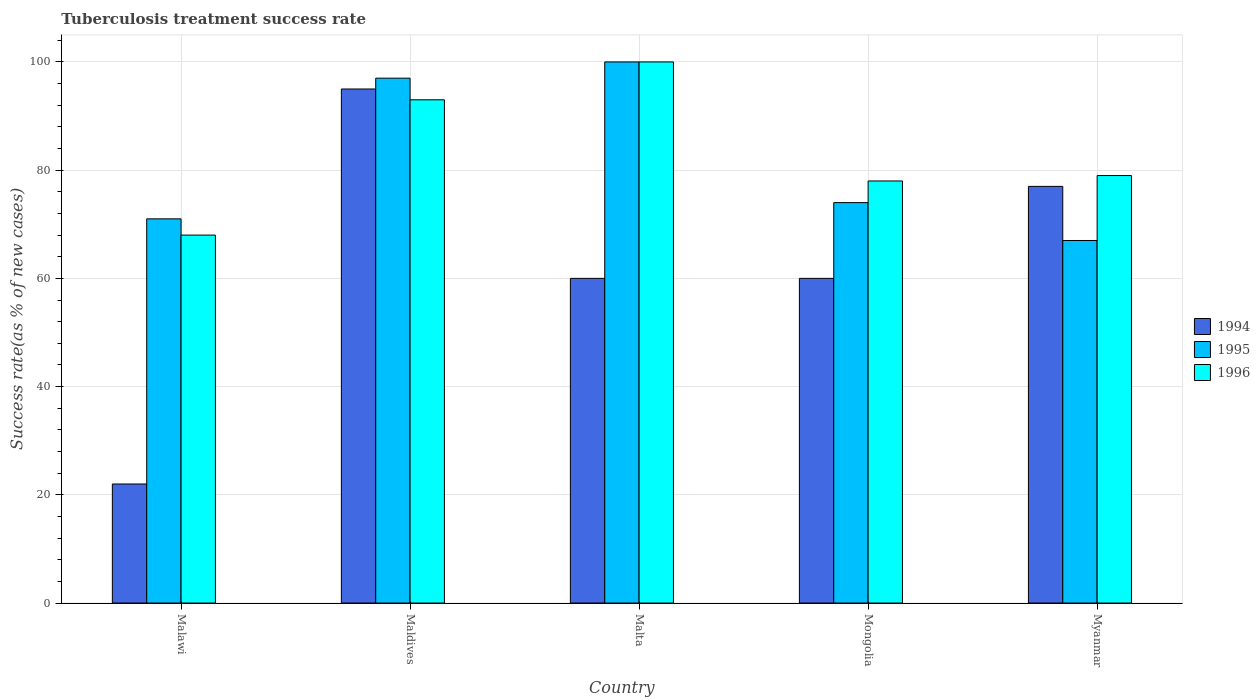How many groups of bars are there?
Give a very brief answer. 5. Are the number of bars on each tick of the X-axis equal?
Your answer should be compact. Yes. What is the label of the 3rd group of bars from the left?
Offer a very short reply. Malta. In how many cases, is the number of bars for a given country not equal to the number of legend labels?
Offer a very short reply. 0. What is the tuberculosis treatment success rate in 1996 in Mongolia?
Offer a terse response. 78. Across all countries, what is the minimum tuberculosis treatment success rate in 1994?
Provide a short and direct response. 22. In which country was the tuberculosis treatment success rate in 1995 maximum?
Provide a succinct answer. Malta. In which country was the tuberculosis treatment success rate in 1994 minimum?
Ensure brevity in your answer.  Malawi. What is the total tuberculosis treatment success rate in 1995 in the graph?
Provide a short and direct response. 409. What is the difference between the tuberculosis treatment success rate in 1994 in Mongolia and the tuberculosis treatment success rate in 1996 in Malawi?
Keep it short and to the point. -8. What is the average tuberculosis treatment success rate in 1995 per country?
Offer a terse response. 81.8. What is the difference between the tuberculosis treatment success rate of/in 1995 and tuberculosis treatment success rate of/in 1994 in Maldives?
Offer a very short reply. 2. What is the ratio of the tuberculosis treatment success rate in 1996 in Malawi to that in Maldives?
Offer a terse response. 0.73. What is the difference between the highest and the second highest tuberculosis treatment success rate in 1996?
Offer a terse response. 7. What is the difference between the highest and the lowest tuberculosis treatment success rate in 1994?
Keep it short and to the point. 73. In how many countries, is the tuberculosis treatment success rate in 1994 greater than the average tuberculosis treatment success rate in 1994 taken over all countries?
Your response must be concise. 2. Is the sum of the tuberculosis treatment success rate in 1994 in Malawi and Myanmar greater than the maximum tuberculosis treatment success rate in 1995 across all countries?
Ensure brevity in your answer.  No. What does the 1st bar from the right in Mongolia represents?
Give a very brief answer. 1996. How many bars are there?
Provide a succinct answer. 15. Are all the bars in the graph horizontal?
Keep it short and to the point. No. What is the title of the graph?
Your response must be concise. Tuberculosis treatment success rate. Does "1964" appear as one of the legend labels in the graph?
Provide a short and direct response. No. What is the label or title of the X-axis?
Keep it short and to the point. Country. What is the label or title of the Y-axis?
Offer a very short reply. Success rate(as % of new cases). What is the Success rate(as % of new cases) of 1994 in Malawi?
Make the answer very short. 22. What is the Success rate(as % of new cases) of 1995 in Malawi?
Give a very brief answer. 71. What is the Success rate(as % of new cases) in 1995 in Maldives?
Provide a short and direct response. 97. What is the Success rate(as % of new cases) of 1996 in Maldives?
Offer a terse response. 93. What is the Success rate(as % of new cases) in 1994 in Malta?
Keep it short and to the point. 60. What is the Success rate(as % of new cases) in 1996 in Malta?
Offer a terse response. 100. What is the Success rate(as % of new cases) of 1994 in Mongolia?
Offer a very short reply. 60. What is the Success rate(as % of new cases) in 1996 in Mongolia?
Provide a short and direct response. 78. What is the Success rate(as % of new cases) of 1996 in Myanmar?
Make the answer very short. 79. Across all countries, what is the maximum Success rate(as % of new cases) in 1996?
Make the answer very short. 100. Across all countries, what is the minimum Success rate(as % of new cases) of 1994?
Keep it short and to the point. 22. What is the total Success rate(as % of new cases) in 1994 in the graph?
Give a very brief answer. 314. What is the total Success rate(as % of new cases) of 1995 in the graph?
Offer a terse response. 409. What is the total Success rate(as % of new cases) of 1996 in the graph?
Make the answer very short. 418. What is the difference between the Success rate(as % of new cases) in 1994 in Malawi and that in Maldives?
Offer a terse response. -73. What is the difference between the Success rate(as % of new cases) in 1996 in Malawi and that in Maldives?
Ensure brevity in your answer.  -25. What is the difference between the Success rate(as % of new cases) in 1994 in Malawi and that in Malta?
Offer a very short reply. -38. What is the difference between the Success rate(as % of new cases) of 1996 in Malawi and that in Malta?
Make the answer very short. -32. What is the difference between the Success rate(as % of new cases) of 1994 in Malawi and that in Mongolia?
Provide a short and direct response. -38. What is the difference between the Success rate(as % of new cases) in 1995 in Malawi and that in Mongolia?
Make the answer very short. -3. What is the difference between the Success rate(as % of new cases) in 1996 in Malawi and that in Mongolia?
Provide a succinct answer. -10. What is the difference between the Success rate(as % of new cases) in 1994 in Malawi and that in Myanmar?
Your response must be concise. -55. What is the difference between the Success rate(as % of new cases) of 1995 in Malawi and that in Myanmar?
Your answer should be very brief. 4. What is the difference between the Success rate(as % of new cases) of 1994 in Maldives and that in Mongolia?
Keep it short and to the point. 35. What is the difference between the Success rate(as % of new cases) in 1995 in Maldives and that in Mongolia?
Ensure brevity in your answer.  23. What is the difference between the Success rate(as % of new cases) of 1996 in Maldives and that in Myanmar?
Keep it short and to the point. 14. What is the difference between the Success rate(as % of new cases) in 1996 in Malta and that in Mongolia?
Make the answer very short. 22. What is the difference between the Success rate(as % of new cases) of 1994 in Malta and that in Myanmar?
Offer a terse response. -17. What is the difference between the Success rate(as % of new cases) of 1995 in Malta and that in Myanmar?
Offer a terse response. 33. What is the difference between the Success rate(as % of new cases) in 1996 in Mongolia and that in Myanmar?
Offer a very short reply. -1. What is the difference between the Success rate(as % of new cases) in 1994 in Malawi and the Success rate(as % of new cases) in 1995 in Maldives?
Offer a terse response. -75. What is the difference between the Success rate(as % of new cases) in 1994 in Malawi and the Success rate(as % of new cases) in 1996 in Maldives?
Keep it short and to the point. -71. What is the difference between the Success rate(as % of new cases) of 1995 in Malawi and the Success rate(as % of new cases) of 1996 in Maldives?
Your response must be concise. -22. What is the difference between the Success rate(as % of new cases) in 1994 in Malawi and the Success rate(as % of new cases) in 1995 in Malta?
Offer a very short reply. -78. What is the difference between the Success rate(as % of new cases) of 1994 in Malawi and the Success rate(as % of new cases) of 1996 in Malta?
Offer a terse response. -78. What is the difference between the Success rate(as % of new cases) of 1994 in Malawi and the Success rate(as % of new cases) of 1995 in Mongolia?
Keep it short and to the point. -52. What is the difference between the Success rate(as % of new cases) in 1994 in Malawi and the Success rate(as % of new cases) in 1996 in Mongolia?
Provide a short and direct response. -56. What is the difference between the Success rate(as % of new cases) of 1994 in Malawi and the Success rate(as % of new cases) of 1995 in Myanmar?
Provide a succinct answer. -45. What is the difference between the Success rate(as % of new cases) of 1994 in Malawi and the Success rate(as % of new cases) of 1996 in Myanmar?
Keep it short and to the point. -57. What is the difference between the Success rate(as % of new cases) of 1995 in Maldives and the Success rate(as % of new cases) of 1996 in Malta?
Give a very brief answer. -3. What is the difference between the Success rate(as % of new cases) in 1994 in Maldives and the Success rate(as % of new cases) in 1996 in Mongolia?
Make the answer very short. 17. What is the difference between the Success rate(as % of new cases) of 1995 in Maldives and the Success rate(as % of new cases) of 1996 in Mongolia?
Offer a terse response. 19. What is the difference between the Success rate(as % of new cases) in 1994 in Maldives and the Success rate(as % of new cases) in 1995 in Myanmar?
Your response must be concise. 28. What is the difference between the Success rate(as % of new cases) of 1994 in Maldives and the Success rate(as % of new cases) of 1996 in Myanmar?
Your answer should be very brief. 16. What is the difference between the Success rate(as % of new cases) in 1994 in Malta and the Success rate(as % of new cases) in 1995 in Mongolia?
Your response must be concise. -14. What is the difference between the Success rate(as % of new cases) of 1994 in Malta and the Success rate(as % of new cases) of 1996 in Mongolia?
Your answer should be very brief. -18. What is the difference between the Success rate(as % of new cases) of 1994 in Malta and the Success rate(as % of new cases) of 1995 in Myanmar?
Offer a very short reply. -7. What is the difference between the Success rate(as % of new cases) of 1994 in Mongolia and the Success rate(as % of new cases) of 1995 in Myanmar?
Offer a very short reply. -7. What is the average Success rate(as % of new cases) of 1994 per country?
Give a very brief answer. 62.8. What is the average Success rate(as % of new cases) of 1995 per country?
Your answer should be compact. 81.8. What is the average Success rate(as % of new cases) in 1996 per country?
Your answer should be compact. 83.6. What is the difference between the Success rate(as % of new cases) of 1994 and Success rate(as % of new cases) of 1995 in Malawi?
Provide a short and direct response. -49. What is the difference between the Success rate(as % of new cases) of 1994 and Success rate(as % of new cases) of 1996 in Malawi?
Ensure brevity in your answer.  -46. What is the difference between the Success rate(as % of new cases) of 1995 and Success rate(as % of new cases) of 1996 in Malawi?
Provide a succinct answer. 3. What is the difference between the Success rate(as % of new cases) of 1994 and Success rate(as % of new cases) of 1995 in Maldives?
Provide a short and direct response. -2. What is the difference between the Success rate(as % of new cases) of 1994 and Success rate(as % of new cases) of 1995 in Malta?
Offer a very short reply. -40. What is the difference between the Success rate(as % of new cases) in 1995 and Success rate(as % of new cases) in 1996 in Mongolia?
Ensure brevity in your answer.  -4. What is the difference between the Success rate(as % of new cases) in 1994 and Success rate(as % of new cases) in 1995 in Myanmar?
Provide a short and direct response. 10. What is the difference between the Success rate(as % of new cases) of 1994 and Success rate(as % of new cases) of 1996 in Myanmar?
Make the answer very short. -2. What is the ratio of the Success rate(as % of new cases) of 1994 in Malawi to that in Maldives?
Provide a succinct answer. 0.23. What is the ratio of the Success rate(as % of new cases) of 1995 in Malawi to that in Maldives?
Your response must be concise. 0.73. What is the ratio of the Success rate(as % of new cases) in 1996 in Malawi to that in Maldives?
Give a very brief answer. 0.73. What is the ratio of the Success rate(as % of new cases) in 1994 in Malawi to that in Malta?
Keep it short and to the point. 0.37. What is the ratio of the Success rate(as % of new cases) of 1995 in Malawi to that in Malta?
Keep it short and to the point. 0.71. What is the ratio of the Success rate(as % of new cases) of 1996 in Malawi to that in Malta?
Give a very brief answer. 0.68. What is the ratio of the Success rate(as % of new cases) of 1994 in Malawi to that in Mongolia?
Offer a very short reply. 0.37. What is the ratio of the Success rate(as % of new cases) in 1995 in Malawi to that in Mongolia?
Your answer should be very brief. 0.96. What is the ratio of the Success rate(as % of new cases) in 1996 in Malawi to that in Mongolia?
Provide a succinct answer. 0.87. What is the ratio of the Success rate(as % of new cases) of 1994 in Malawi to that in Myanmar?
Your answer should be very brief. 0.29. What is the ratio of the Success rate(as % of new cases) in 1995 in Malawi to that in Myanmar?
Keep it short and to the point. 1.06. What is the ratio of the Success rate(as % of new cases) of 1996 in Malawi to that in Myanmar?
Give a very brief answer. 0.86. What is the ratio of the Success rate(as % of new cases) of 1994 in Maldives to that in Malta?
Keep it short and to the point. 1.58. What is the ratio of the Success rate(as % of new cases) of 1994 in Maldives to that in Mongolia?
Ensure brevity in your answer.  1.58. What is the ratio of the Success rate(as % of new cases) in 1995 in Maldives to that in Mongolia?
Provide a succinct answer. 1.31. What is the ratio of the Success rate(as % of new cases) of 1996 in Maldives to that in Mongolia?
Provide a succinct answer. 1.19. What is the ratio of the Success rate(as % of new cases) of 1994 in Maldives to that in Myanmar?
Your answer should be very brief. 1.23. What is the ratio of the Success rate(as % of new cases) of 1995 in Maldives to that in Myanmar?
Give a very brief answer. 1.45. What is the ratio of the Success rate(as % of new cases) of 1996 in Maldives to that in Myanmar?
Your answer should be very brief. 1.18. What is the ratio of the Success rate(as % of new cases) in 1994 in Malta to that in Mongolia?
Ensure brevity in your answer.  1. What is the ratio of the Success rate(as % of new cases) of 1995 in Malta to that in Mongolia?
Offer a very short reply. 1.35. What is the ratio of the Success rate(as % of new cases) of 1996 in Malta to that in Mongolia?
Provide a succinct answer. 1.28. What is the ratio of the Success rate(as % of new cases) of 1994 in Malta to that in Myanmar?
Provide a succinct answer. 0.78. What is the ratio of the Success rate(as % of new cases) in 1995 in Malta to that in Myanmar?
Provide a succinct answer. 1.49. What is the ratio of the Success rate(as % of new cases) of 1996 in Malta to that in Myanmar?
Your response must be concise. 1.27. What is the ratio of the Success rate(as % of new cases) in 1994 in Mongolia to that in Myanmar?
Give a very brief answer. 0.78. What is the ratio of the Success rate(as % of new cases) in 1995 in Mongolia to that in Myanmar?
Provide a succinct answer. 1.1. What is the ratio of the Success rate(as % of new cases) of 1996 in Mongolia to that in Myanmar?
Your answer should be compact. 0.99. What is the difference between the highest and the second highest Success rate(as % of new cases) of 1994?
Give a very brief answer. 18. What is the difference between the highest and the second highest Success rate(as % of new cases) of 1995?
Ensure brevity in your answer.  3. What is the difference between the highest and the second highest Success rate(as % of new cases) of 1996?
Your answer should be compact. 7. 